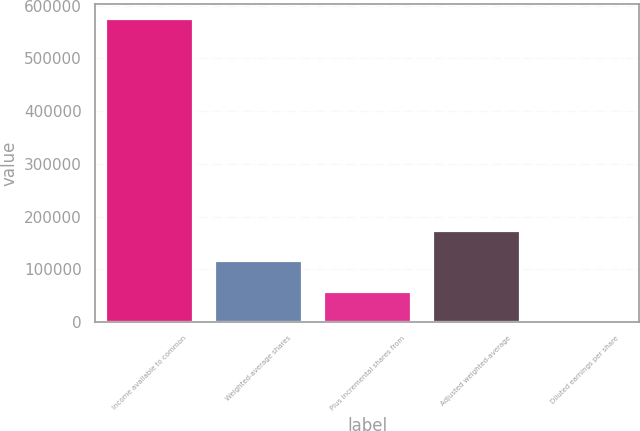Convert chart. <chart><loc_0><loc_0><loc_500><loc_500><bar_chart><fcel>Income available to common<fcel>Weighted-average shares<fcel>Plus incremental shares from<fcel>Adjusted weighted-average<fcel>Diluted earnings per share<nl><fcel>573942<fcel>114792<fcel>57398.7<fcel>172186<fcel>4.95<nl></chart> 